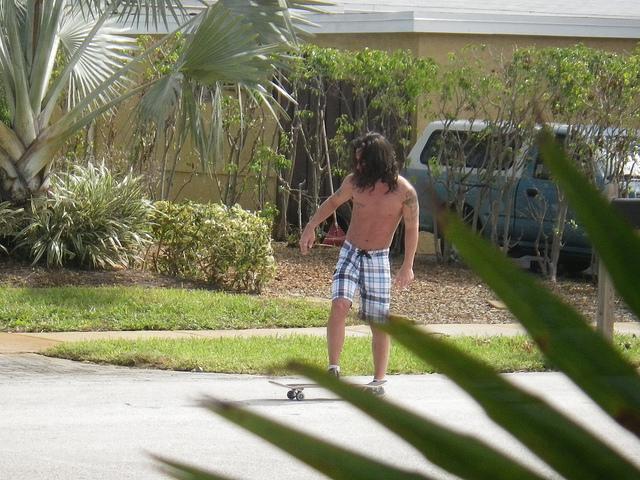How many decors does the bus have?
Give a very brief answer. 0. 